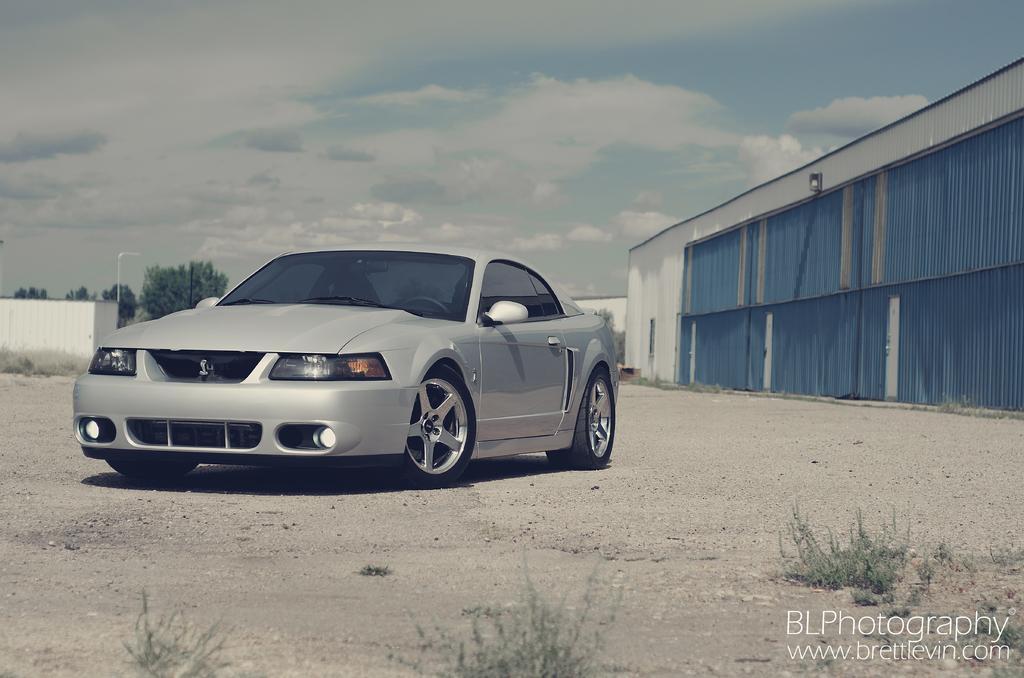Describe this image in one or two sentences. In this image, we can see a car on the ground. We can also see some grass. On the right side, we can see a building. There are some trees. In the background, we can see the sky. 